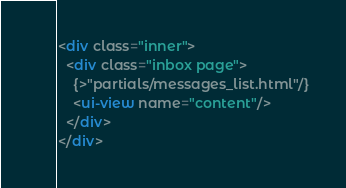<code> <loc_0><loc_0><loc_500><loc_500><_HTML_><div class="inner">
  <div class="inbox page">
    {>"partials/messages_list.html"/}
    <ui-view name="content"/>
  </div>
</div>
</code> 